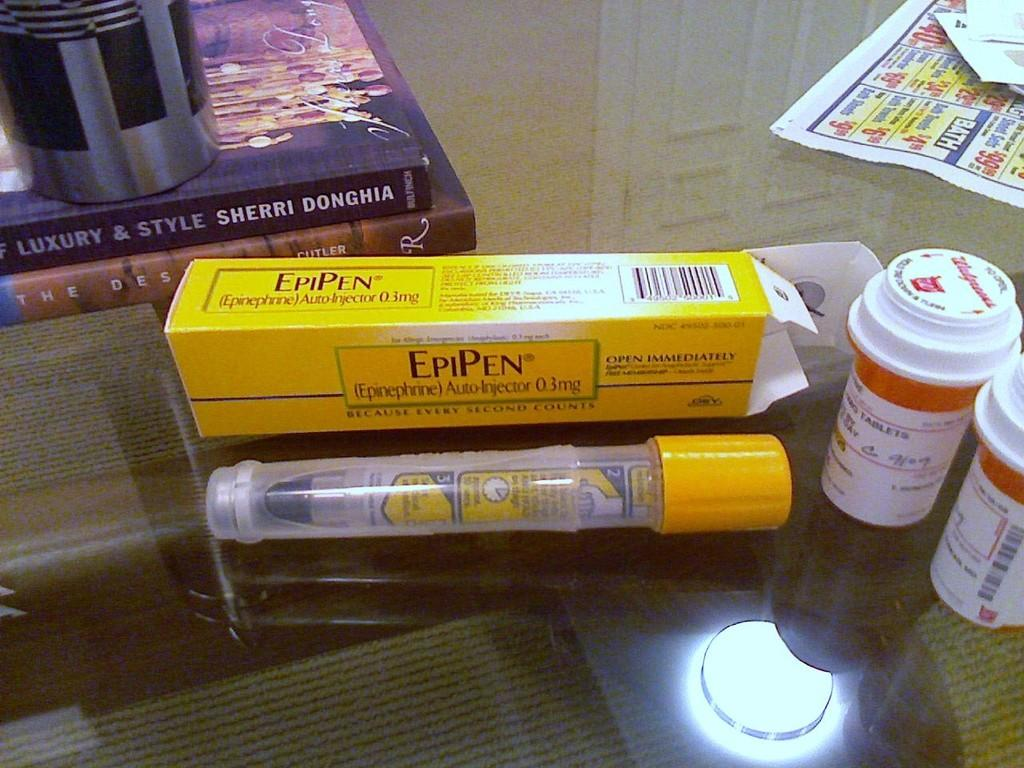<image>
Offer a succinct explanation of the picture presented. Epipen medicine on a table next to a book by Sherri Donghia. 